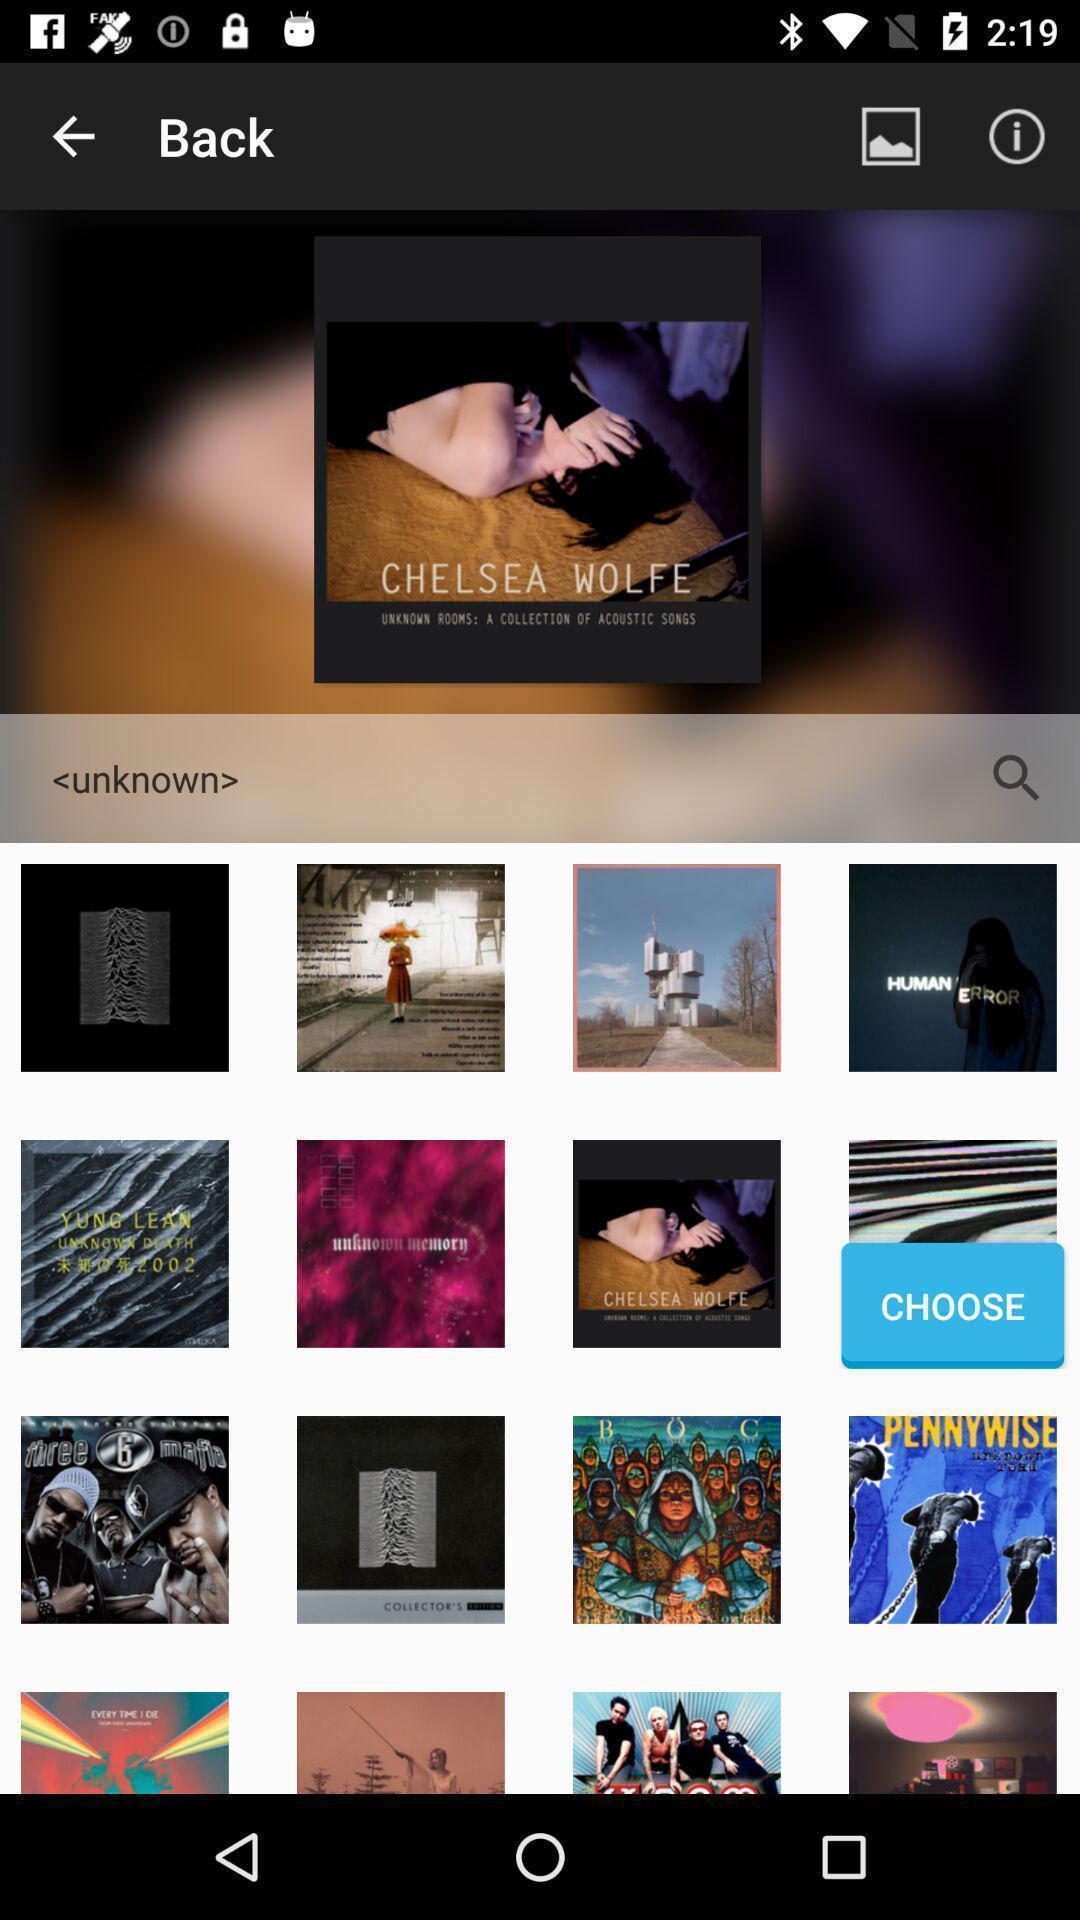Describe the key features of this screenshot. Screen showing various images. 